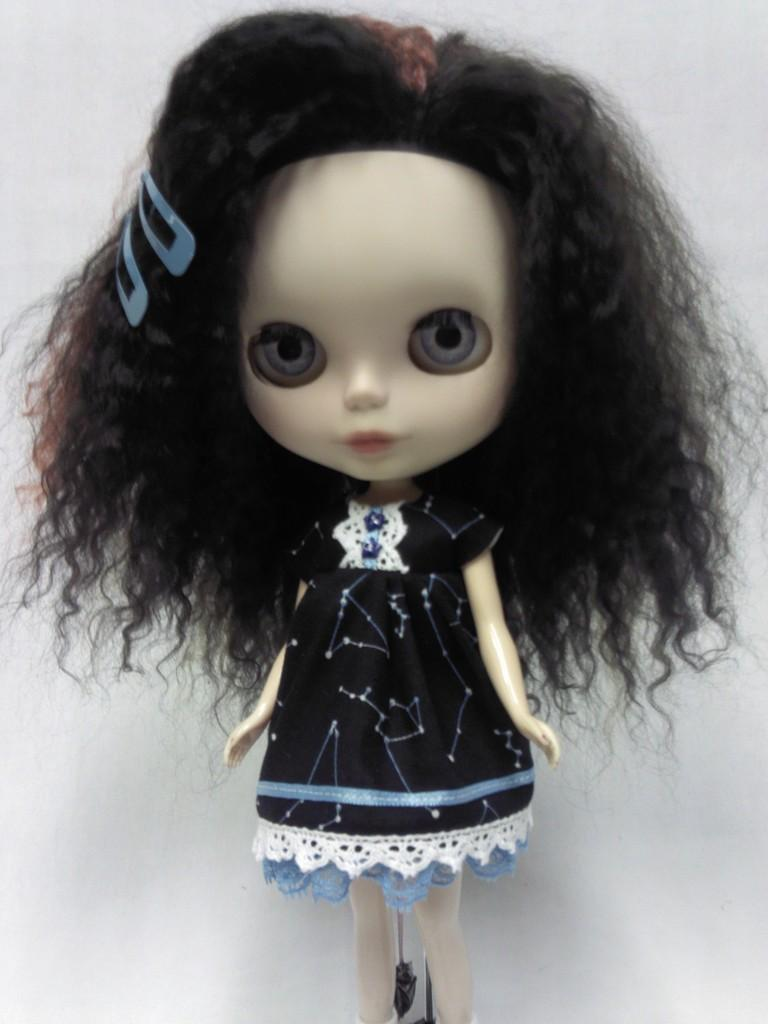What is the main subject in the center of the image? There is a doll in the center of the image. How is the doll dressed? The doll has a different costume. What color is the background of the image? The background of the image is white. Can you tell me how many spots the doll has on its costume? There is no mention of spots on the doll's costume in the image. 